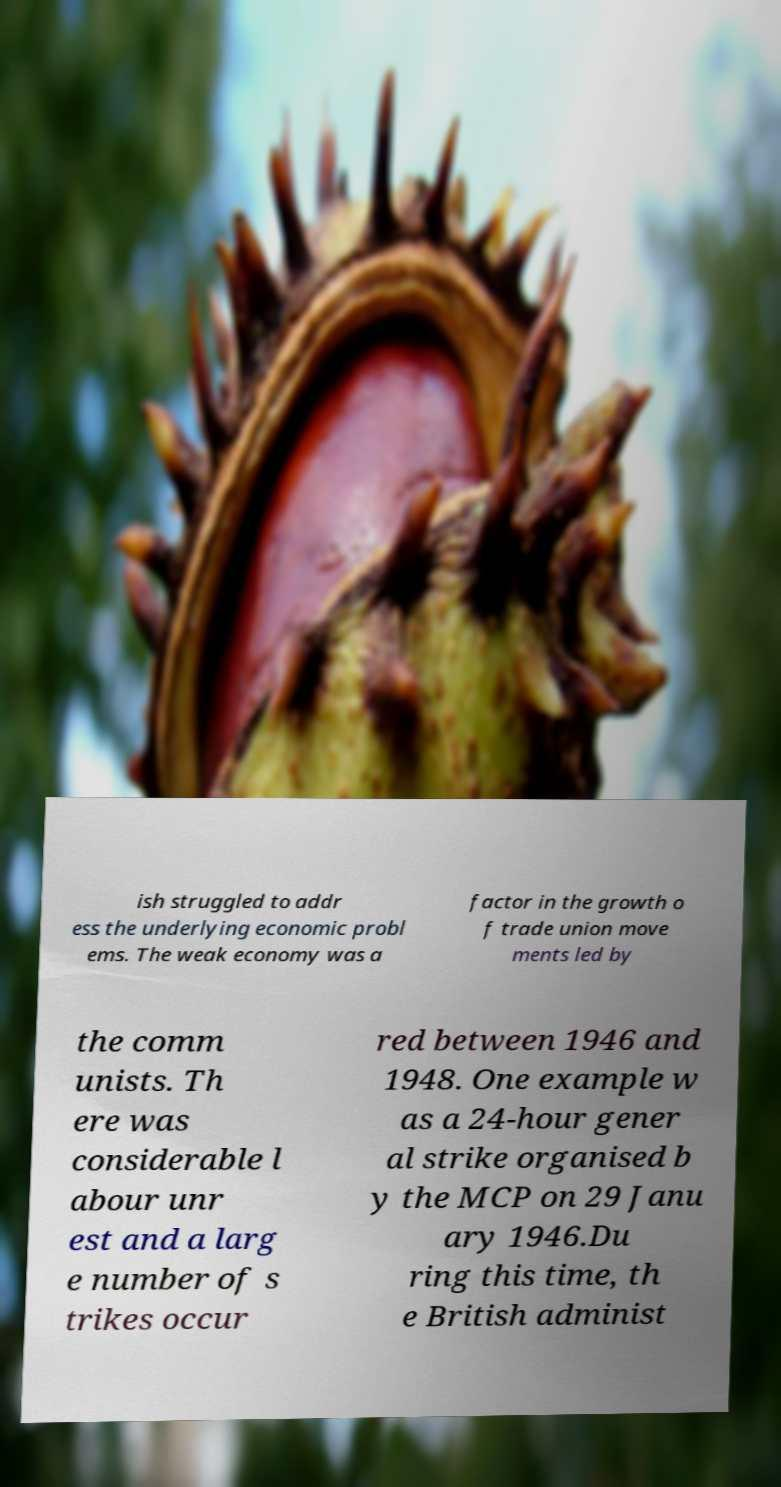Please identify and transcribe the text found in this image. ish struggled to addr ess the underlying economic probl ems. The weak economy was a factor in the growth o f trade union move ments led by the comm unists. Th ere was considerable l abour unr est and a larg e number of s trikes occur red between 1946 and 1948. One example w as a 24-hour gener al strike organised b y the MCP on 29 Janu ary 1946.Du ring this time, th e British administ 